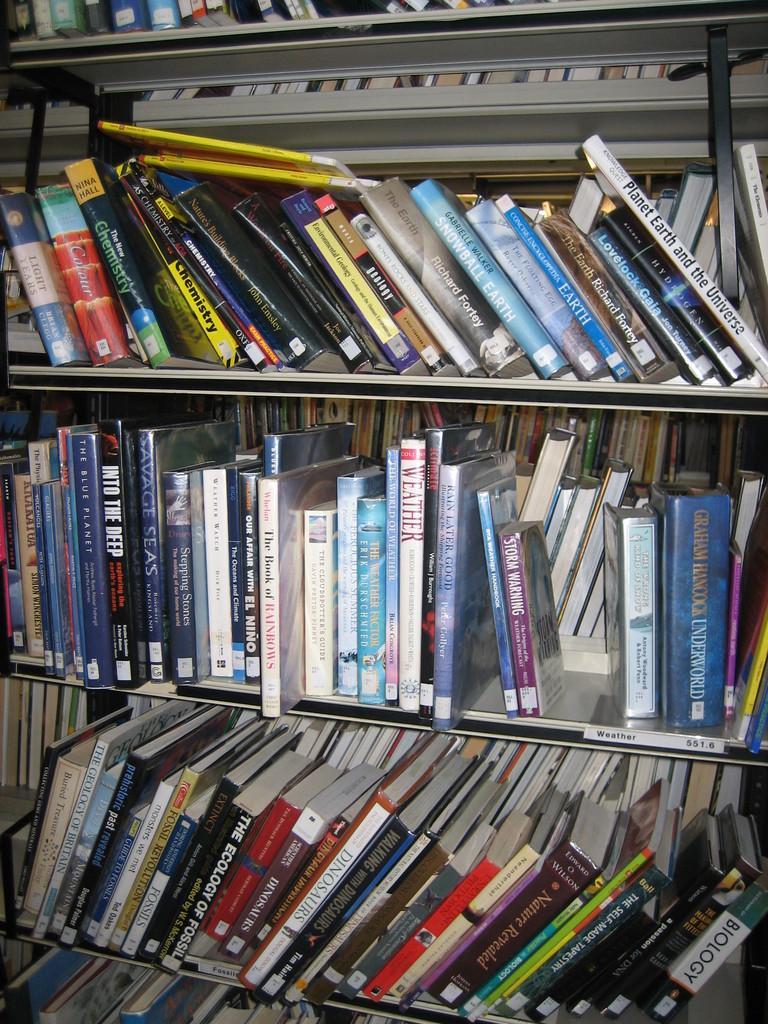Please provide a concise description of this image. In this image, we can see books in the rack. 